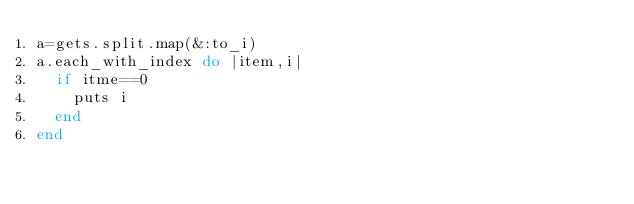<code> <loc_0><loc_0><loc_500><loc_500><_Ruby_>a=gets.split.map(&:to_i)
a.each_with_index do |item,i|
  if itme==0
    puts i
  end
end
</code> 